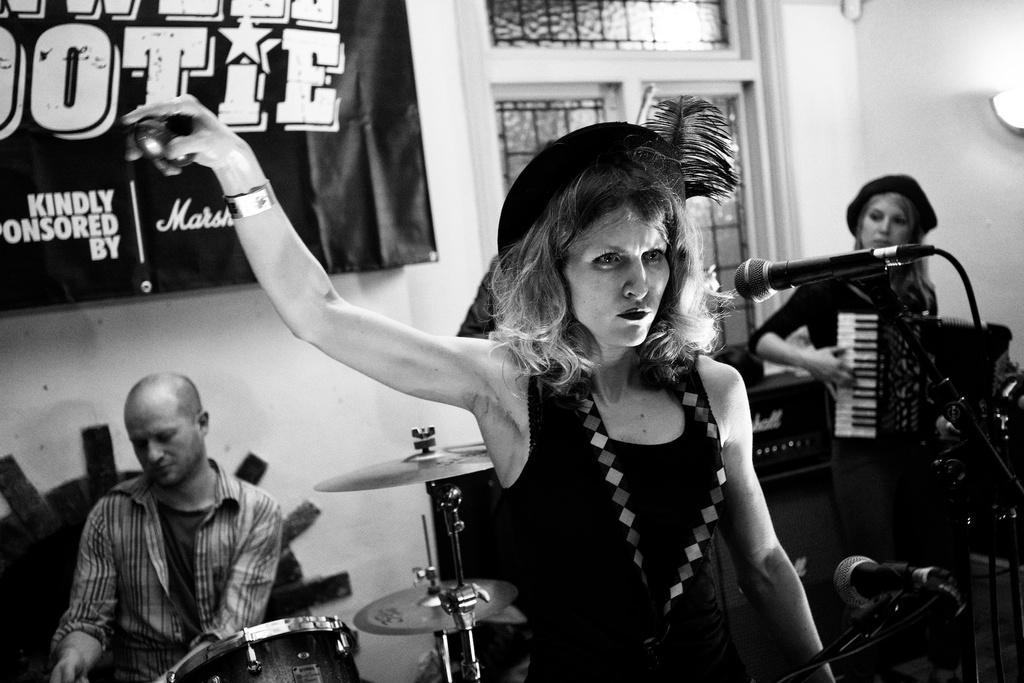In one or two sentences, can you explain what this image depicts? In this image I can see three persons. In front the person is standing and holding an object, background I can see few musical instruments and I can also see the banner and few windows and the image is in black and white. 